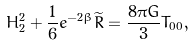Convert formula to latex. <formula><loc_0><loc_0><loc_500><loc_500>H _ { 2 } ^ { 2 } + \frac { 1 } { 6 } e ^ { - 2 \beta } \widetilde { R } = \frac { 8 \pi G } { 3 } T _ { 0 0 } ,</formula> 